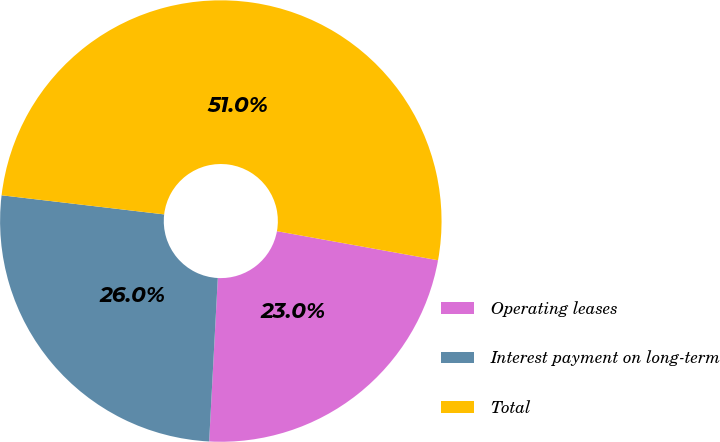<chart> <loc_0><loc_0><loc_500><loc_500><pie_chart><fcel>Operating leases<fcel>Interest payment on long-term<fcel>Total<nl><fcel>23.0%<fcel>26.02%<fcel>50.98%<nl></chart> 